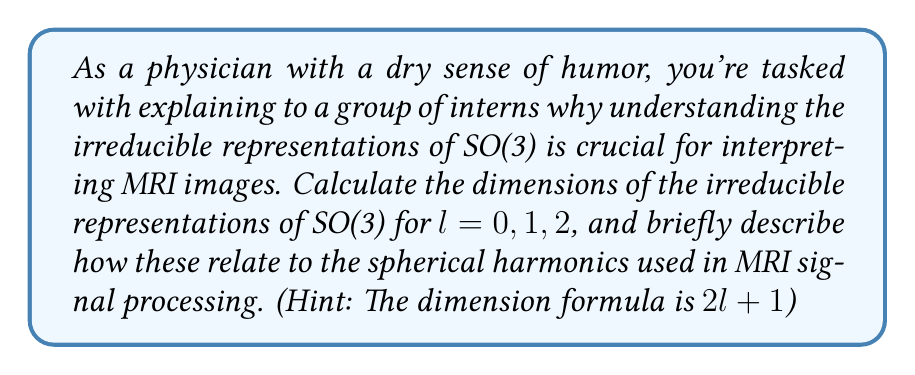Could you help me with this problem? Let's approach this step-by-step:

1) The rotation group SO(3) represents all possible rotations in 3D space. Its irreducible representations are labeled by the angular momentum quantum number $l = 0, 1, 2, ...$

2) The dimension of each irreducible representation is given by the formula:

   $$\text{dim} = 2l + 1$$

3) Let's calculate for $l = 0, 1, 2$:

   For $l = 0$: $\text{dim} = 2(0) + 1 = 1$
   For $l = 1$: $\text{dim} = 2(1) + 1 = 3$
   For $l = 2$: $\text{dim} = 2(2) + 1 = 5$

4) These dimensions correspond to the number of spherical harmonics for each $l$ value:
   - $l = 0$: One spherical harmonic (constant function)
   - $l = 1$: Three spherical harmonics (dipole functions)
   - $l = 2$: Five spherical harmonics (quadrupole functions)

5) In MRI, spherical harmonics are used to describe the spatial distribution of the magnetic field. The $l = 0$ term represents the uniform field, $l = 1$ terms represent linear gradients, and $l = 2$ terms represent quadratic field variations.

6) Understanding these representations helps in:
   - Shimming: Adjusting the magnetic field for uniformity
   - Gradient coil design: Creating precise linear field gradients
   - Image artifact correction: Identifying and correcting field inhomogeneities

As a physician might quip: "Understanding SO(3) representations in MRI is like knowing the right dance moves at a particle physics disco - it helps you interpret all the spins correctly!"
Answer: Dimensions: 1, 3, 5 for $l = 0, 1, 2$ respectively. Applications: field uniformity, gradient design, artifact correction. 